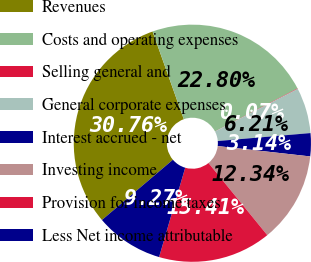<chart> <loc_0><loc_0><loc_500><loc_500><pie_chart><fcel>Revenues<fcel>Costs and operating expenses<fcel>Selling general and<fcel>General corporate expenses<fcel>Interest accrued - net<fcel>Investing income<fcel>Provision for income taxes<fcel>Less Net income attributable<nl><fcel>30.76%<fcel>22.8%<fcel>0.07%<fcel>6.21%<fcel>3.14%<fcel>12.34%<fcel>15.41%<fcel>9.27%<nl></chart> 